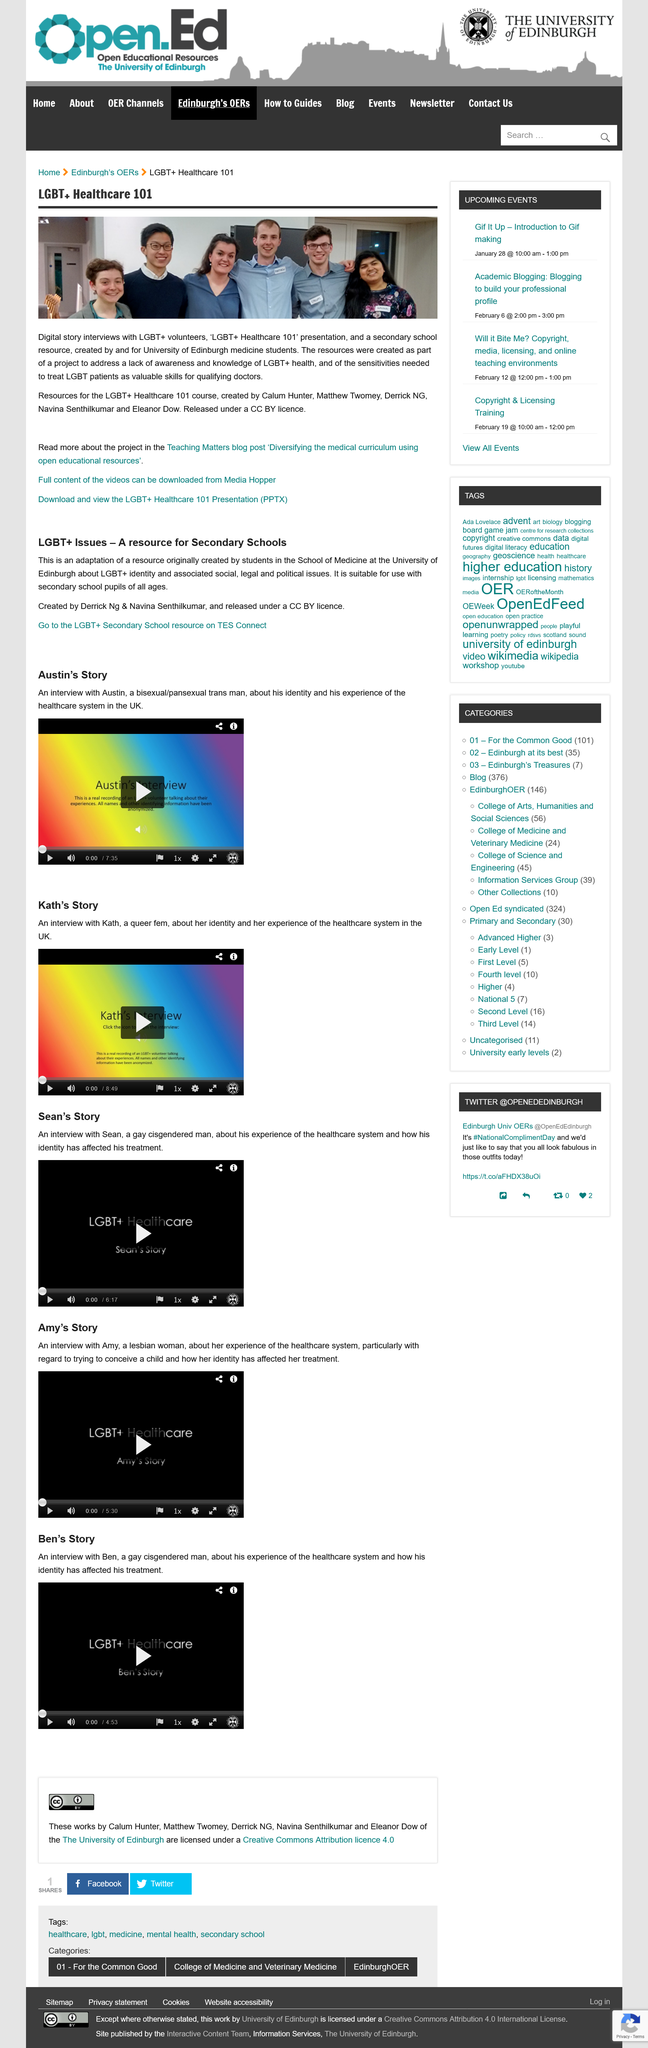Indicate a few pertinent items in this graphic. There are six individuals depicted in the image featured in the article "LGBT+Healthcare 101". You can read more about the project on the Teaching Matters blogpost titled 'diversifying the medical curriculum using open educational resources.' The resources were created as part of a project to address the lack of awareness and knowledge of LGBT+ health topics. 